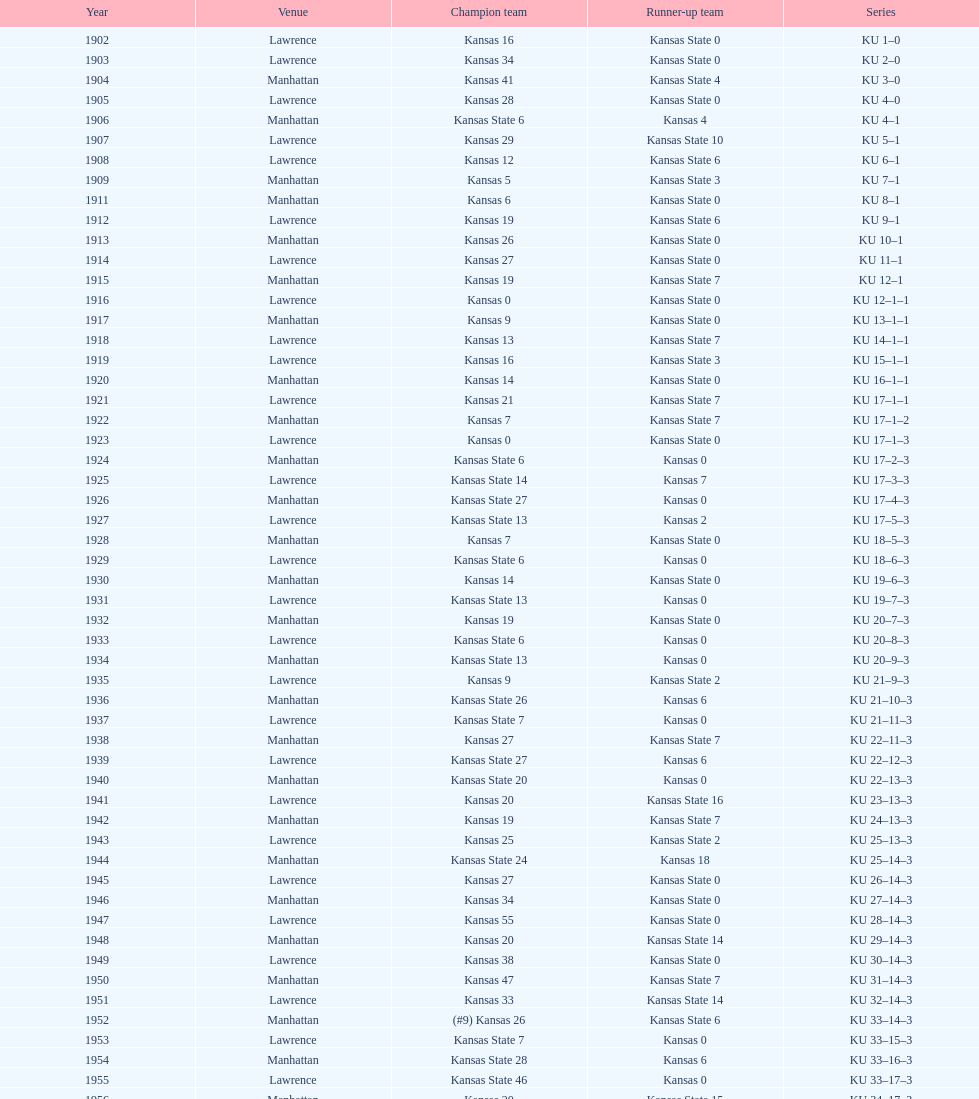When was the first game that kansas state won by double digits? 1926. 